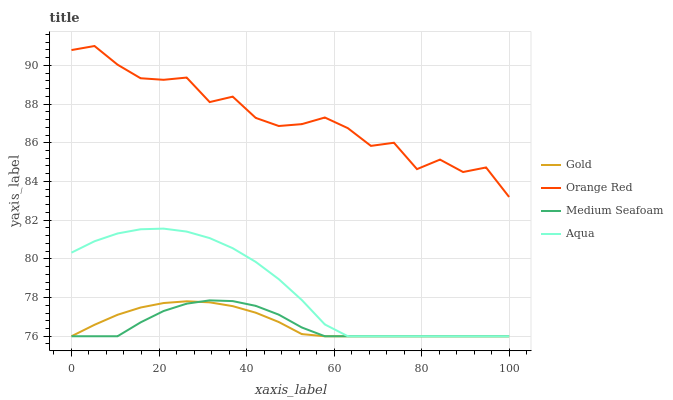Does Medium Seafoam have the minimum area under the curve?
Answer yes or no. Yes. Does Orange Red have the maximum area under the curve?
Answer yes or no. Yes. Does Gold have the minimum area under the curve?
Answer yes or no. No. Does Gold have the maximum area under the curve?
Answer yes or no. No. Is Gold the smoothest?
Answer yes or no. Yes. Is Orange Red the roughest?
Answer yes or no. Yes. Is Orange Red the smoothest?
Answer yes or no. No. Is Gold the roughest?
Answer yes or no. No. Does Aqua have the lowest value?
Answer yes or no. Yes. Does Orange Red have the lowest value?
Answer yes or no. No. Does Orange Red have the highest value?
Answer yes or no. Yes. Does Gold have the highest value?
Answer yes or no. No. Is Gold less than Orange Red?
Answer yes or no. Yes. Is Orange Red greater than Aqua?
Answer yes or no. Yes. Does Gold intersect Medium Seafoam?
Answer yes or no. Yes. Is Gold less than Medium Seafoam?
Answer yes or no. No. Is Gold greater than Medium Seafoam?
Answer yes or no. No. Does Gold intersect Orange Red?
Answer yes or no. No. 